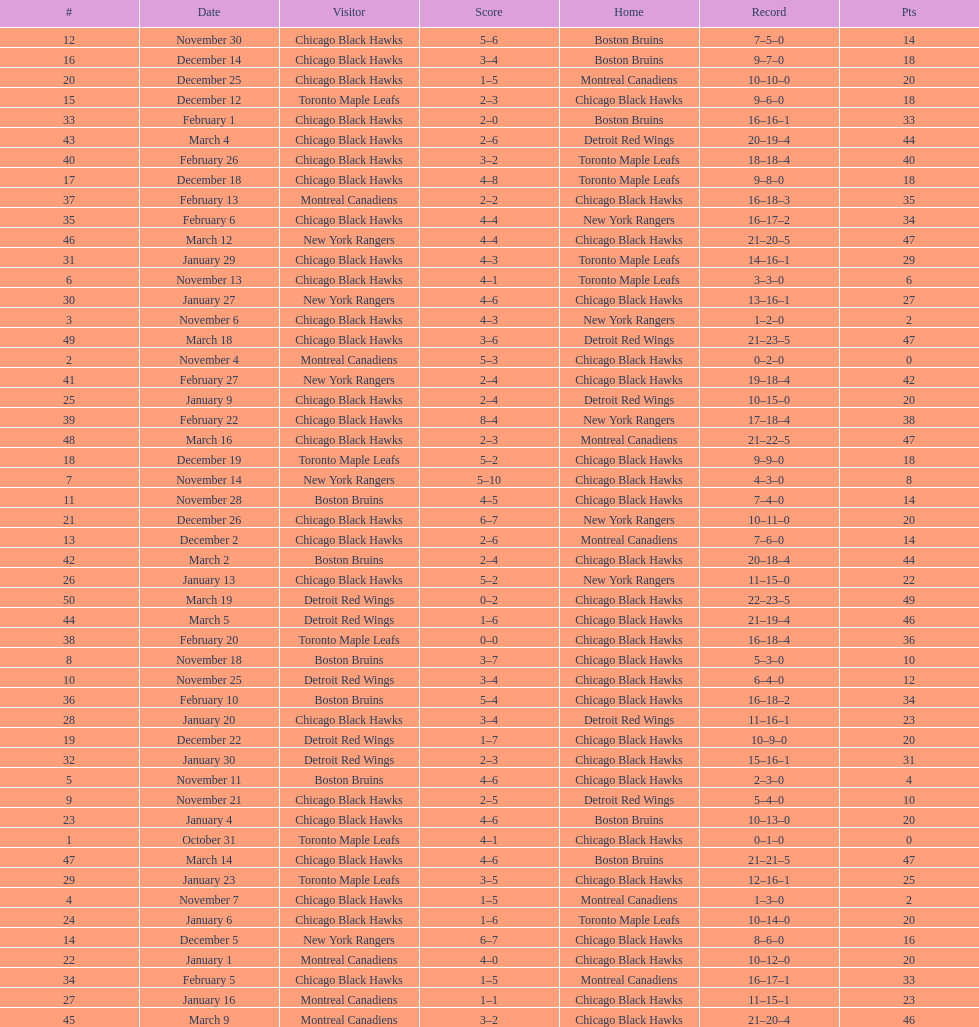On december 14 was the home team the chicago black hawks or the boston bruins? Boston Bruins. 